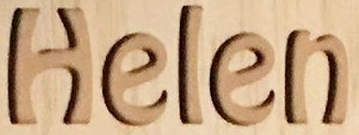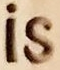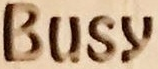Read the text from these images in sequence, separated by a semicolon. Helen; is; Busy 